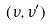Convert formula to latex. <formula><loc_0><loc_0><loc_500><loc_500>( \nu , \nu ^ { \prime } )</formula> 